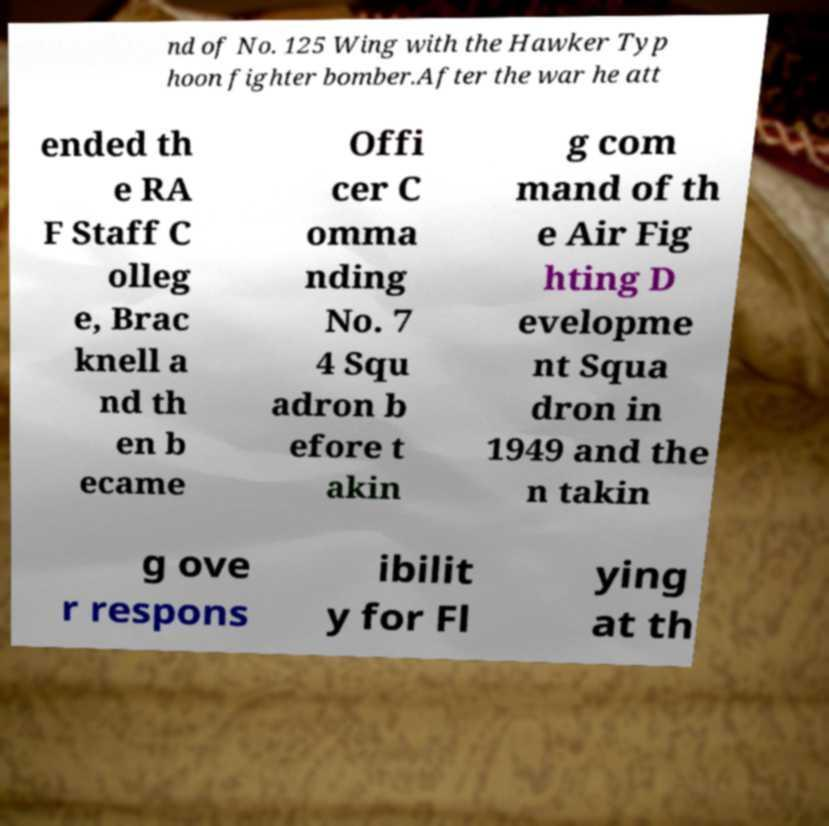Please identify and transcribe the text found in this image. nd of No. 125 Wing with the Hawker Typ hoon fighter bomber.After the war he att ended th e RA F Staff C olleg e, Brac knell a nd th en b ecame Offi cer C omma nding No. 7 4 Squ adron b efore t akin g com mand of th e Air Fig hting D evelopme nt Squa dron in 1949 and the n takin g ove r respons ibilit y for Fl ying at th 